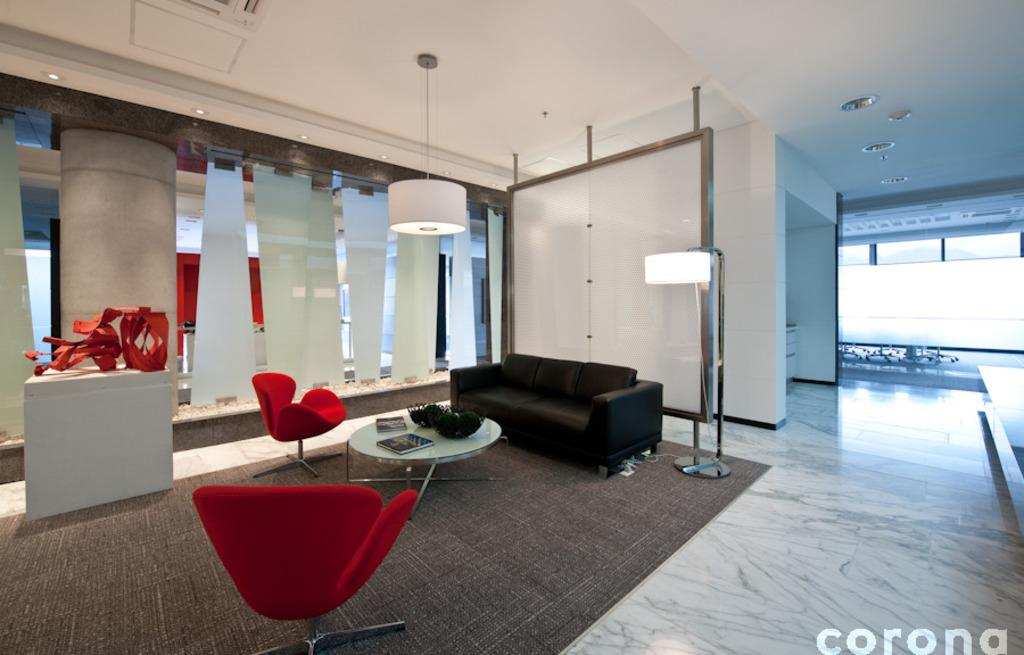How many chairs are in the image? There are two chairs in the image. What other furniture is present in the image? There is a table and a sofa in the image. Can you describe the lighting in the image? There is a light in the image. How many stitches are visible on the sofa in the image? There are no stitches visible on the sofa in the image, as it is not a textile item. 